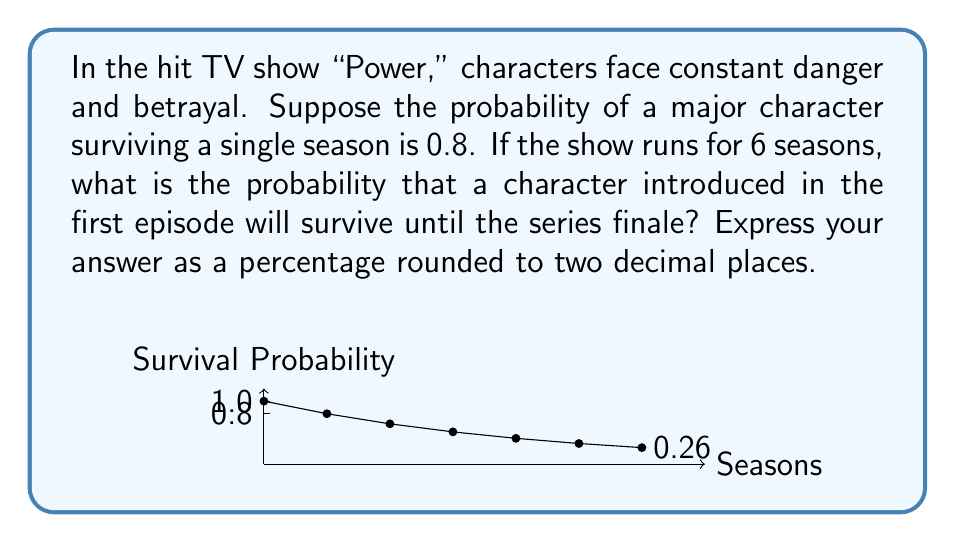Can you answer this question? To solve this problem, we need to use the concept of independent events in probability theory. Each season can be considered an independent event where the character has a chance of survival.

Given:
- Probability of surviving a single season: $p = 0.8$
- Number of seasons: $n = 6$

The probability of surviving all 6 seasons is the product of surviving each individual season:

$$P(\text{surviving all seasons}) = p^n = 0.8^6$$

Let's calculate this step by step:

1) $0.8^6 = 0.8 \times 0.8 \times 0.8 \times 0.8 \times 0.8 \times 0.8$
2) $= 0.262144$

To express this as a percentage:

3) $0.262144 \times 100 = 26.2144\%$

Rounding to two decimal places:

4) $26.21\%$

This result aligns with the intuition that surviving multiple seasons in a high-stakes drama like "Power" becomes increasingly unlikely as the number of seasons increases, even with a relatively high per-season survival probability.
Answer: $26.21\%$ 